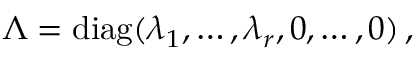Convert formula to latex. <formula><loc_0><loc_0><loc_500><loc_500>\begin{array} { r } { \Lambda = d i a g ( \lambda _ { 1 } , \dots , \lambda _ { r } , 0 , \dots , 0 ) \, , } \end{array}</formula> 